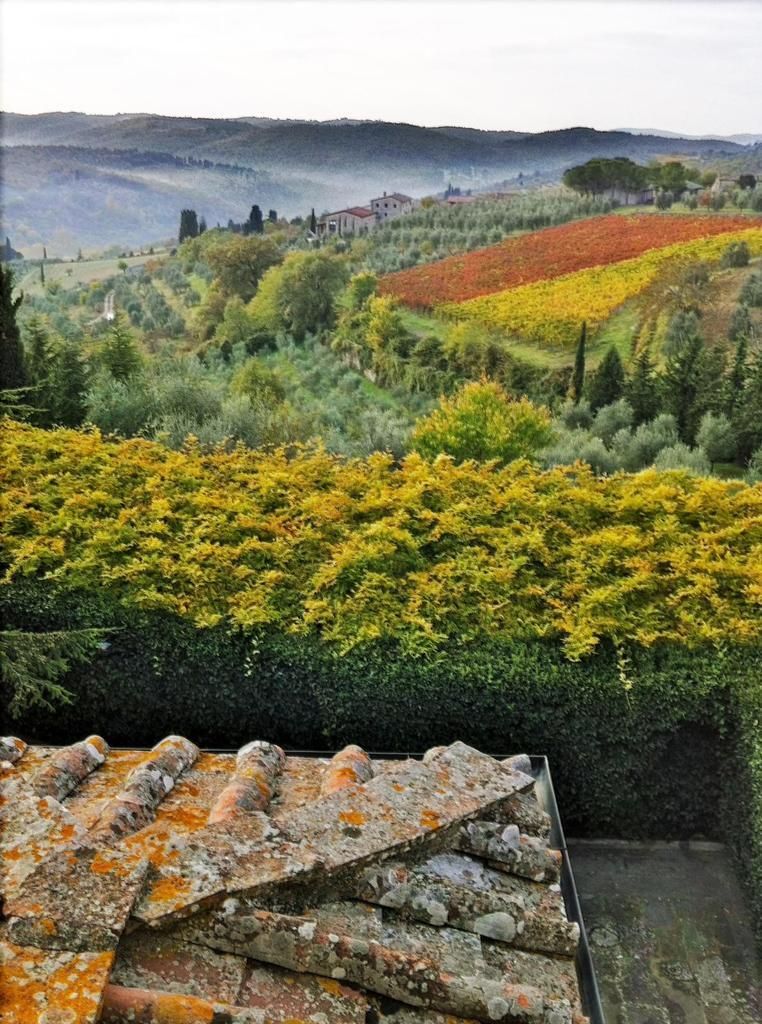What type of natural vegetation can be seen in the image? There is a group of trees in the image. What type of man-made structures are present in the image? There are buildings in the image. What can be seen in the distance in the image? There is a group of mountains visible in the background of the image. What is visible above the trees and buildings in the image? The sky is visible in the background of the image. Can you see a robin perched on the string in the image? There is no robin or string present in the image. What type of pot is visible in the image? There is no pot present in the image. 